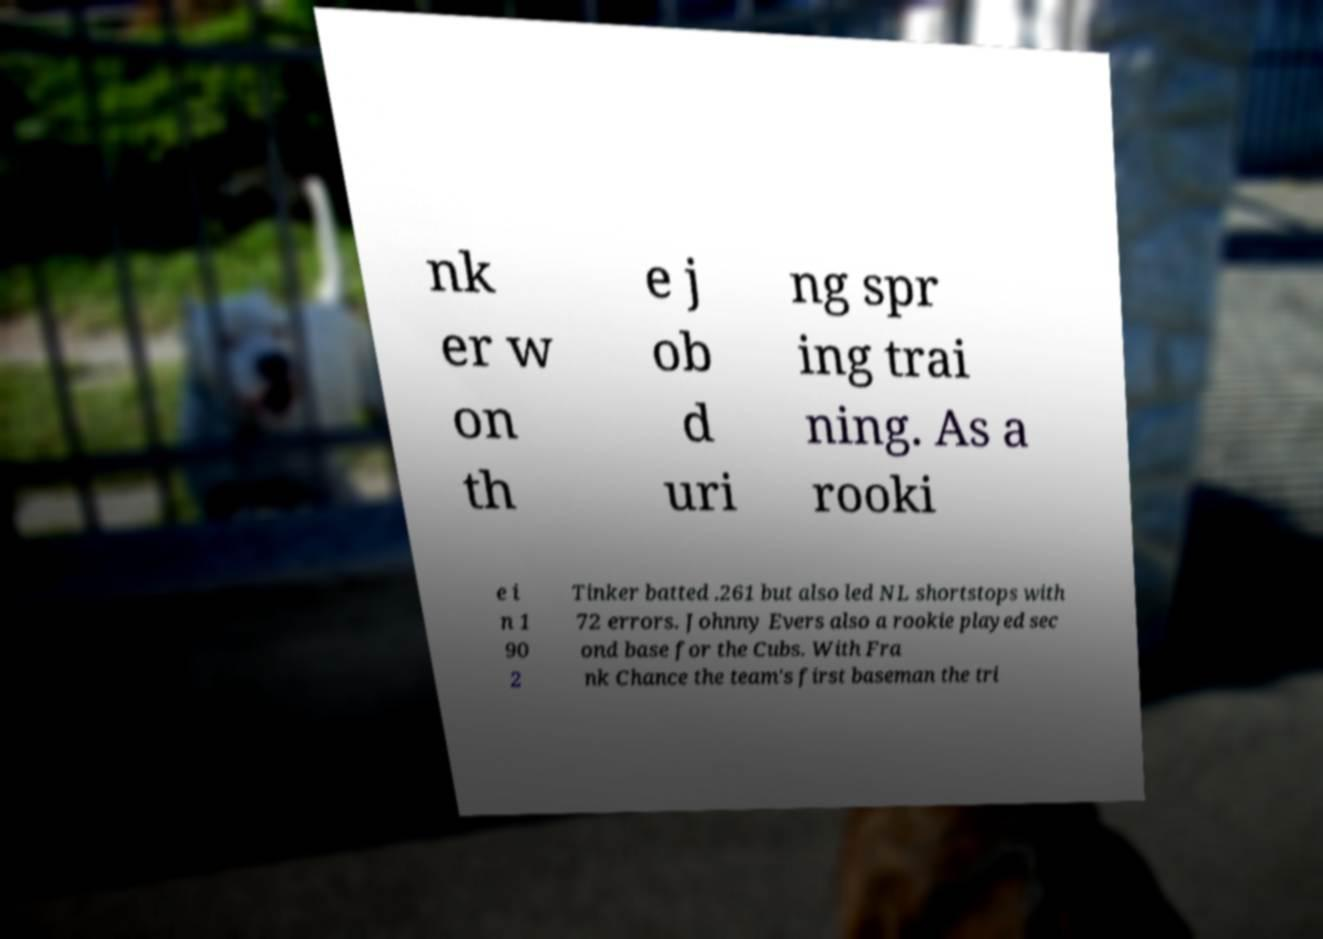Can you accurately transcribe the text from the provided image for me? nk er w on th e j ob d uri ng spr ing trai ning. As a rooki e i n 1 90 2 Tinker batted .261 but also led NL shortstops with 72 errors. Johnny Evers also a rookie played sec ond base for the Cubs. With Fra nk Chance the team's first baseman the tri 